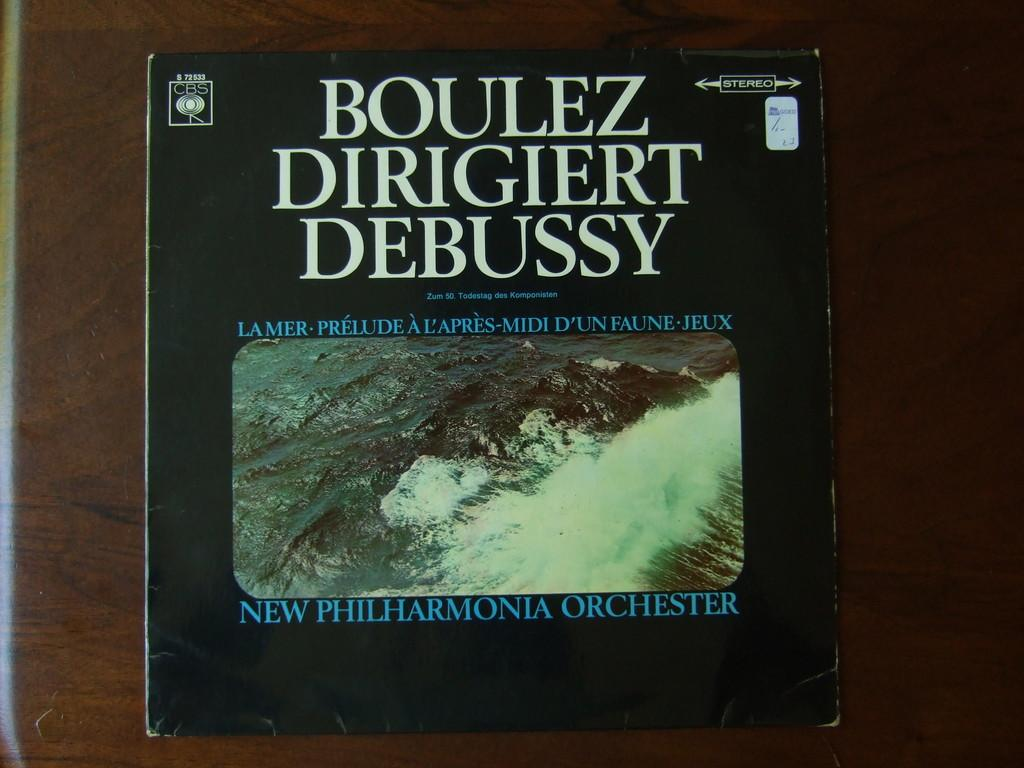Provide a one-sentence caption for the provided image. An old record sleeve tells us the LP is of an orchestra playing Debussy classical music. 